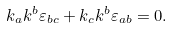<formula> <loc_0><loc_0><loc_500><loc_500>k _ { a } k ^ { b } \varepsilon _ { b c } + k _ { c } k ^ { b } \varepsilon _ { a b } = 0 .</formula> 